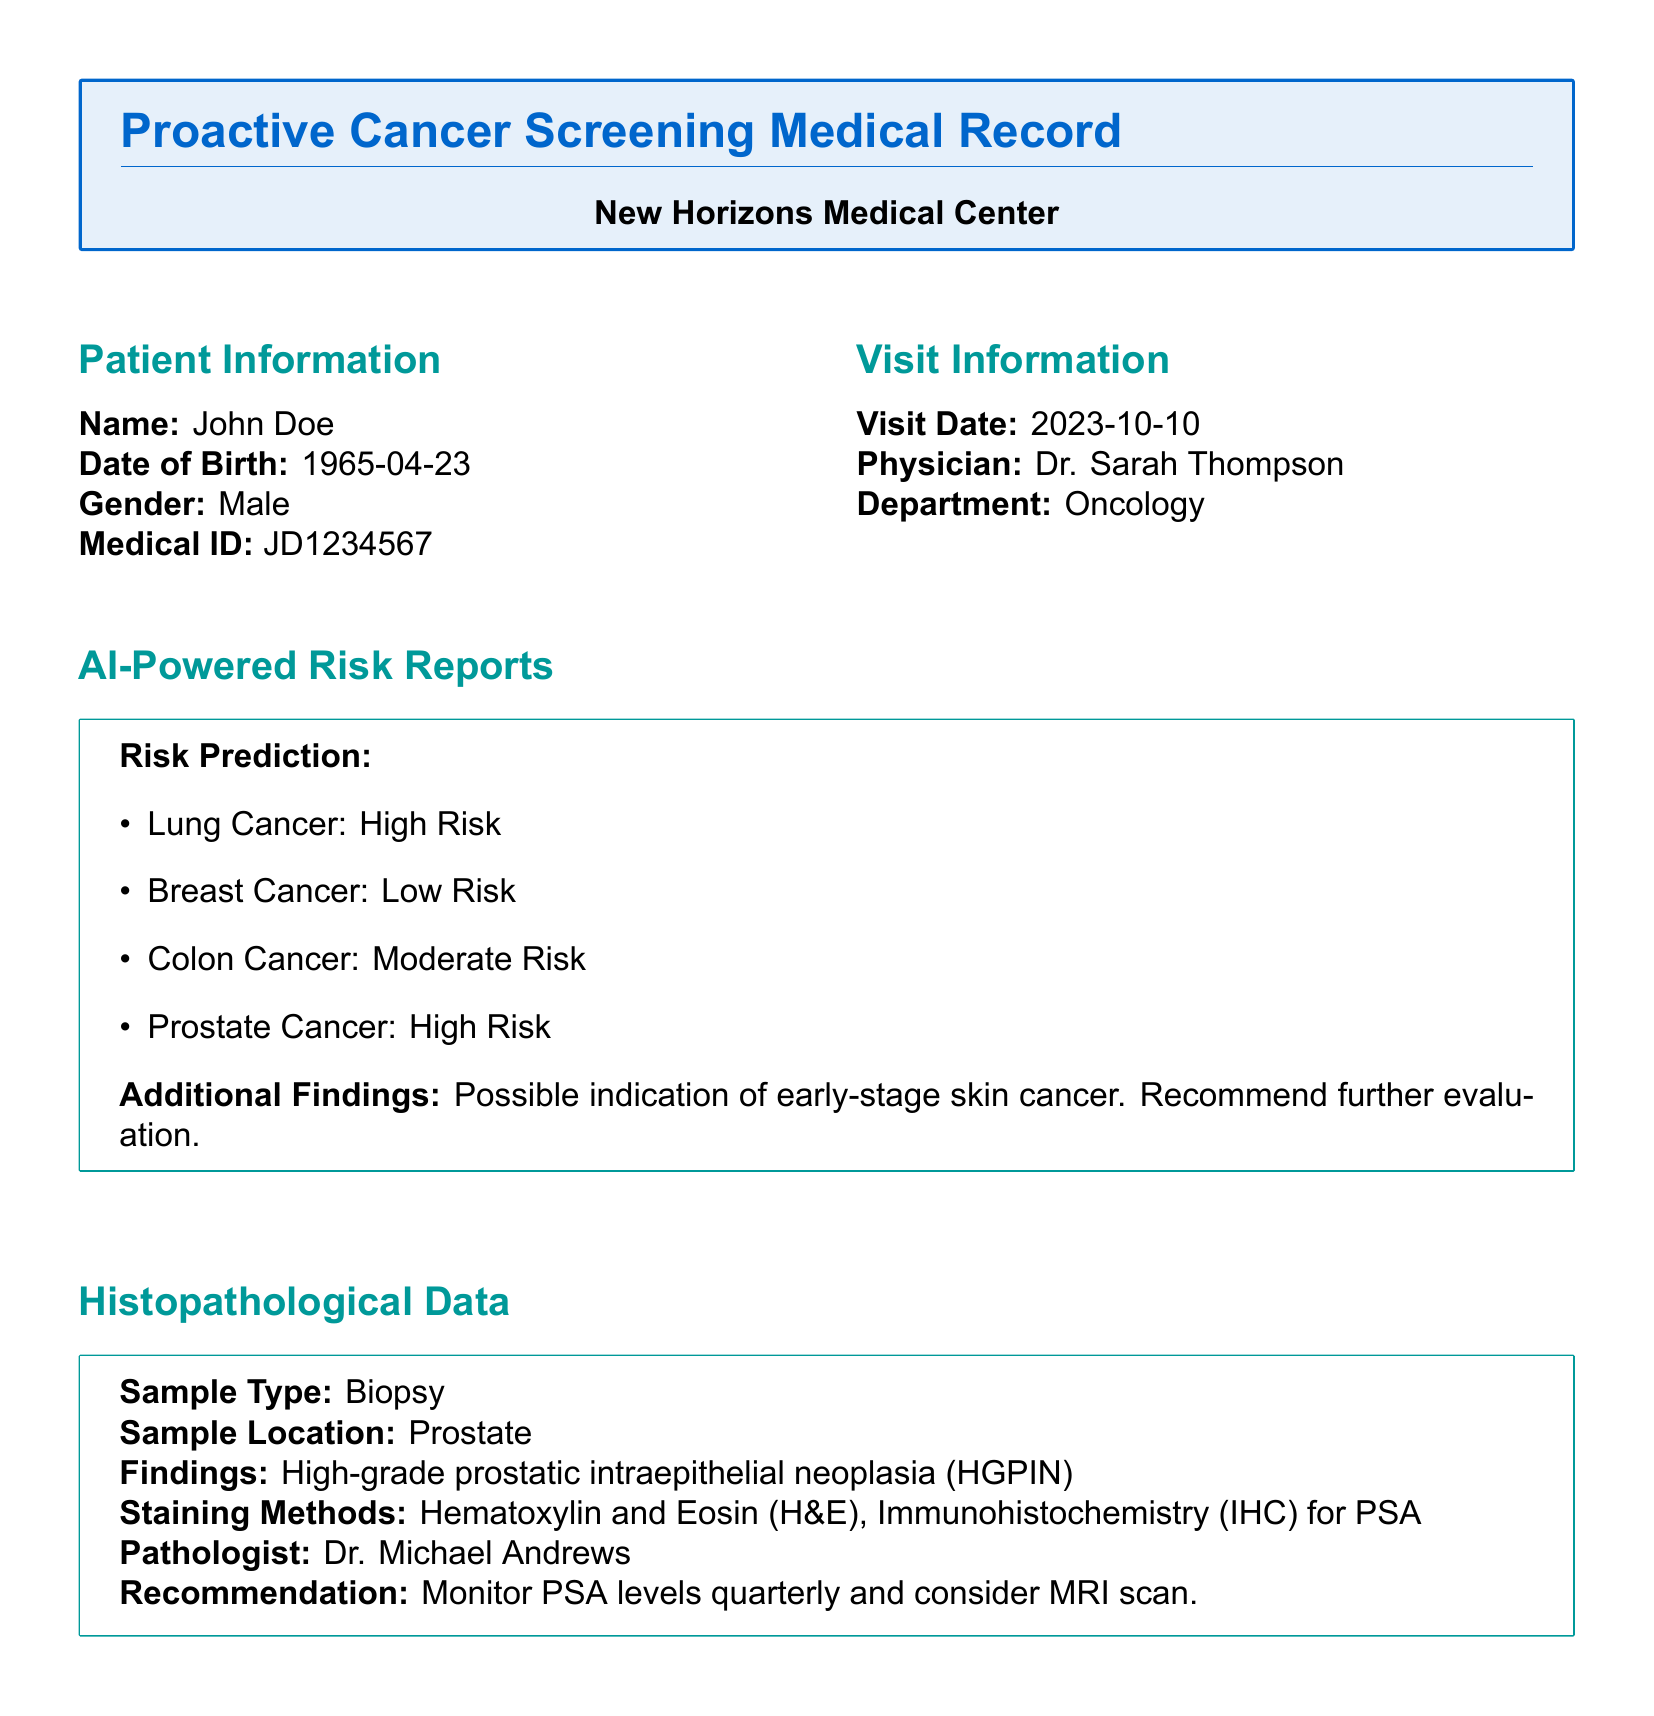What is the patient's name? The patient's name is mentioned in the Patient Information section.
Answer: John Doe What is the visit date? The visit date is provided in the Visit Information section.
Answer: 2023-10-10 What is the recommendation regarding the prostate? The recommendation is derived from the histopathological findings.
Answer: Monitor PSA levels quarterly and consider MRI scan What is the patient's risk level for lung cancer? The risk level for lung cancer is part of the AI-Powered Risk Reports section.
Answer: High Risk What lifestyle changes are recommended for the patient? The lifestyle recommendations are listed in the Follow-Up Plan section.
Answer: Quit smoking to reduce lung cancer risk What additional evaluation is suggested for the skin? The recommendation is based on the AI-Powered Risk Reports findings.
Answer: Recommend further evaluation What is the sample type for the histopathological data? The sample type is specified in the Histopathological Data section.
Answer: Biopsy Who is the pathologist that reviewed the findings? The pathologist's name is provided in the Histopathological Data section.
Answer: Dr. Michael Andrews What was the patient's concern during the visit? The patient concern is noted in the Notes section of the document.
Answer: Recent skin changes on his back 